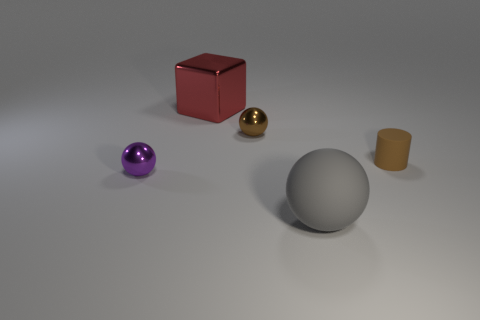Add 4 small brown metallic things. How many objects exist? 9 Subtract all cylinders. How many objects are left? 4 Subtract 0 yellow cylinders. How many objects are left? 5 Subtract all large red metal blocks. Subtract all large things. How many objects are left? 2 Add 2 cylinders. How many cylinders are left? 3 Add 5 purple shiny cylinders. How many purple shiny cylinders exist? 5 